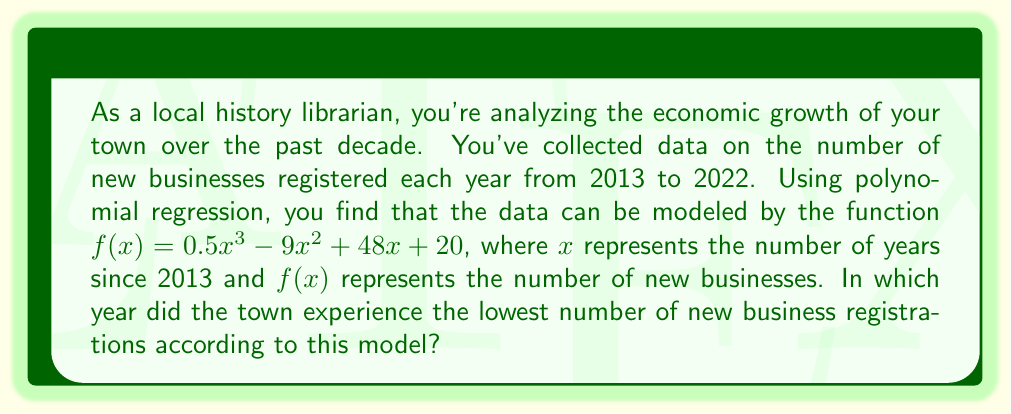Help me with this question. To find the year with the lowest number of new business registrations, we need to follow these steps:

1) First, we need to find the minimum point of the function $f(x) = 0.5x^3 - 9x^2 + 48x + 20$.

2) To do this, we find the derivative of $f(x)$:
   $f'(x) = 1.5x^2 - 18x + 48$

3) Set the derivative equal to zero and solve for x:
   $1.5x^2 - 18x + 48 = 0$

4) This is a quadratic equation. We can solve it using the quadratic formula:
   $x = \frac{-b \pm \sqrt{b^2 - 4ac}}{2a}$

   Where $a = 1.5$, $b = -18$, and $c = 48$

5) Plugging in these values:
   $x = \frac{18 \pm \sqrt{(-18)^2 - 4(1.5)(48)}}{2(1.5)}$
   $= \frac{18 \pm \sqrt{324 - 288}}{3}$
   $= \frac{18 \pm 6}{3}$

6) This gives us two solutions: $x = 8$ or $x = 4$

7) To determine which of these is the minimum, we can check the second derivative:
   $f''(x) = 3x - 18$

8) At $x = 4$, $f''(4) = -6 < 0$, indicating a maximum
   At $x = 8$, $f''(8) = 6 > 0$, indicating a minimum

9) Therefore, the minimum occurs at $x = 8$

10) Since $x$ represents the number of years since 2013, $x = 8$ corresponds to the year 2021.
Answer: 2021 